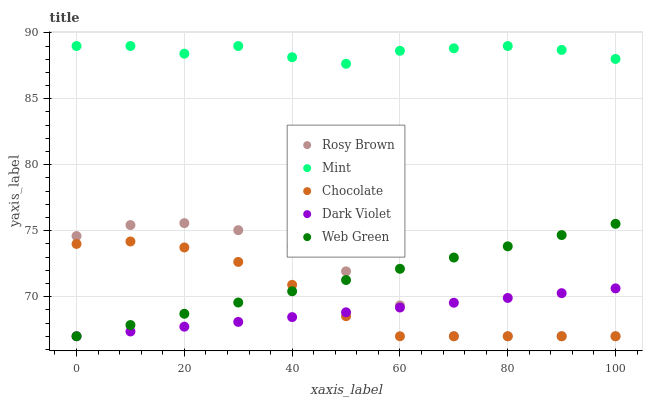Does Dark Violet have the minimum area under the curve?
Answer yes or no. Yes. Does Mint have the maximum area under the curve?
Answer yes or no. Yes. Does Web Green have the minimum area under the curve?
Answer yes or no. No. Does Web Green have the maximum area under the curve?
Answer yes or no. No. Is Web Green the smoothest?
Answer yes or no. Yes. Is Mint the roughest?
Answer yes or no. Yes. Is Mint the smoothest?
Answer yes or no. No. Is Web Green the roughest?
Answer yes or no. No. Does Rosy Brown have the lowest value?
Answer yes or no. Yes. Does Mint have the lowest value?
Answer yes or no. No. Does Mint have the highest value?
Answer yes or no. Yes. Does Web Green have the highest value?
Answer yes or no. No. Is Web Green less than Mint?
Answer yes or no. Yes. Is Mint greater than Dark Violet?
Answer yes or no. Yes. Does Chocolate intersect Dark Violet?
Answer yes or no. Yes. Is Chocolate less than Dark Violet?
Answer yes or no. No. Is Chocolate greater than Dark Violet?
Answer yes or no. No. Does Web Green intersect Mint?
Answer yes or no. No. 